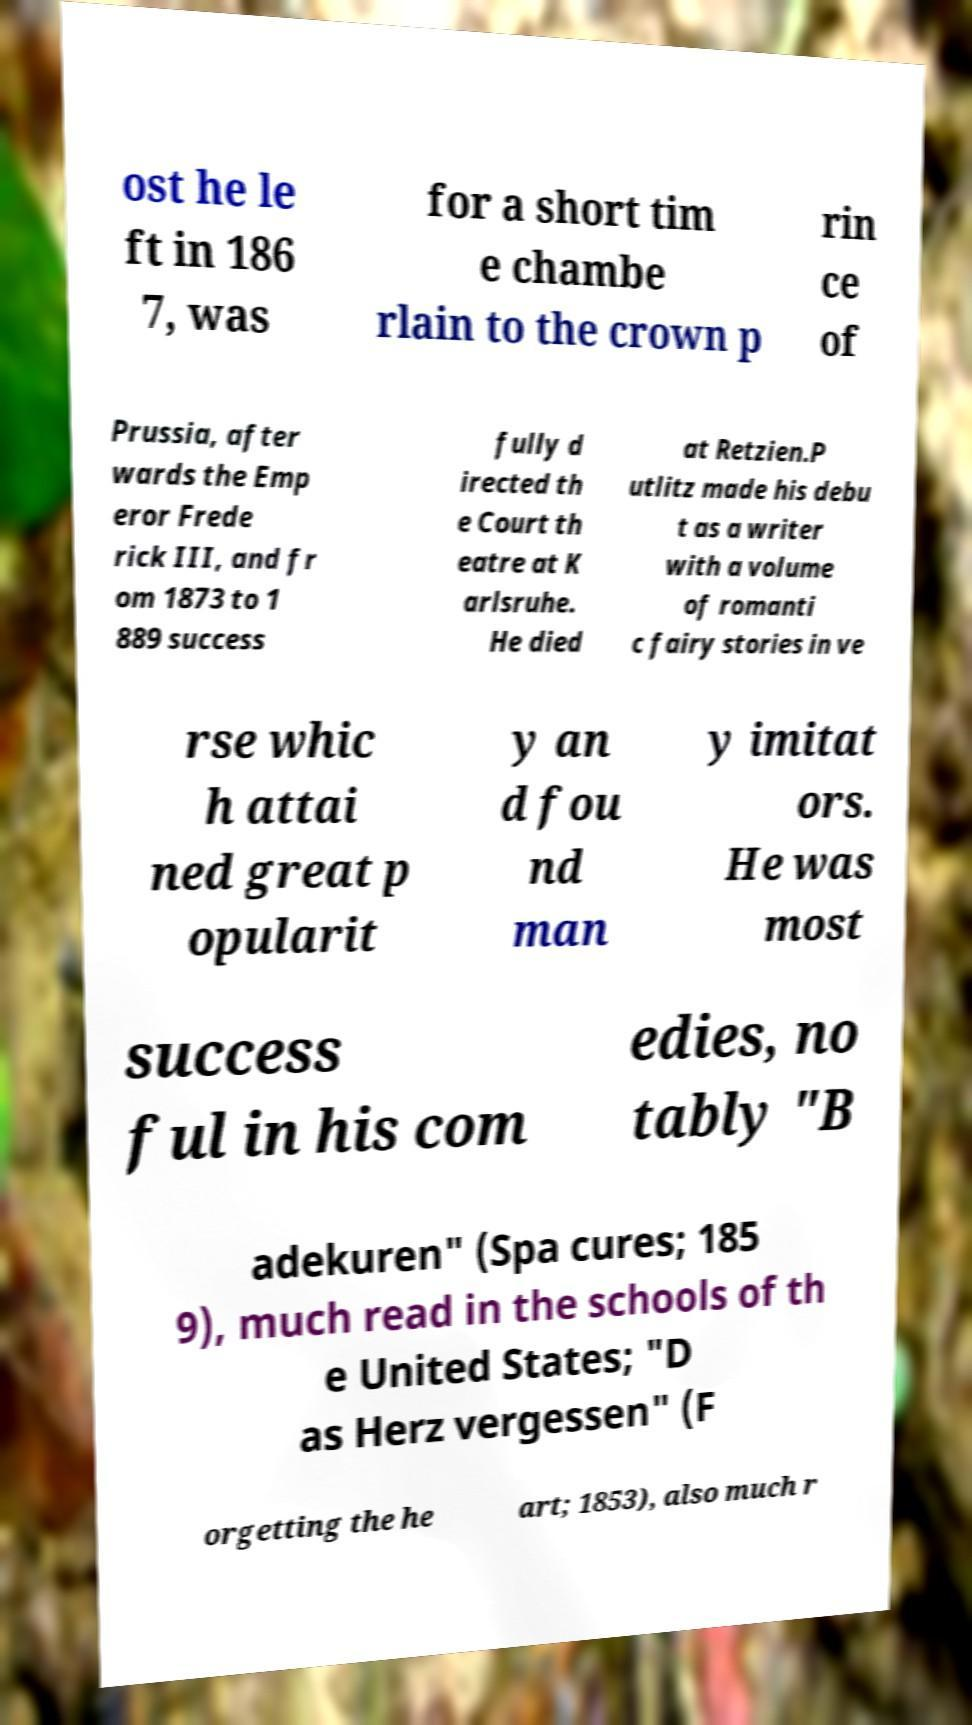Can you read and provide the text displayed in the image?This photo seems to have some interesting text. Can you extract and type it out for me? ost he le ft in 186 7, was for a short tim e chambe rlain to the crown p rin ce of Prussia, after wards the Emp eror Frede rick III, and fr om 1873 to 1 889 success fully d irected th e Court th eatre at K arlsruhe. He died at Retzien.P utlitz made his debu t as a writer with a volume of romanti c fairy stories in ve rse whic h attai ned great p opularit y an d fou nd man y imitat ors. He was most success ful in his com edies, no tably "B adekuren" (Spa cures; 185 9), much read in the schools of th e United States; "D as Herz vergessen" (F orgetting the he art; 1853), also much r 